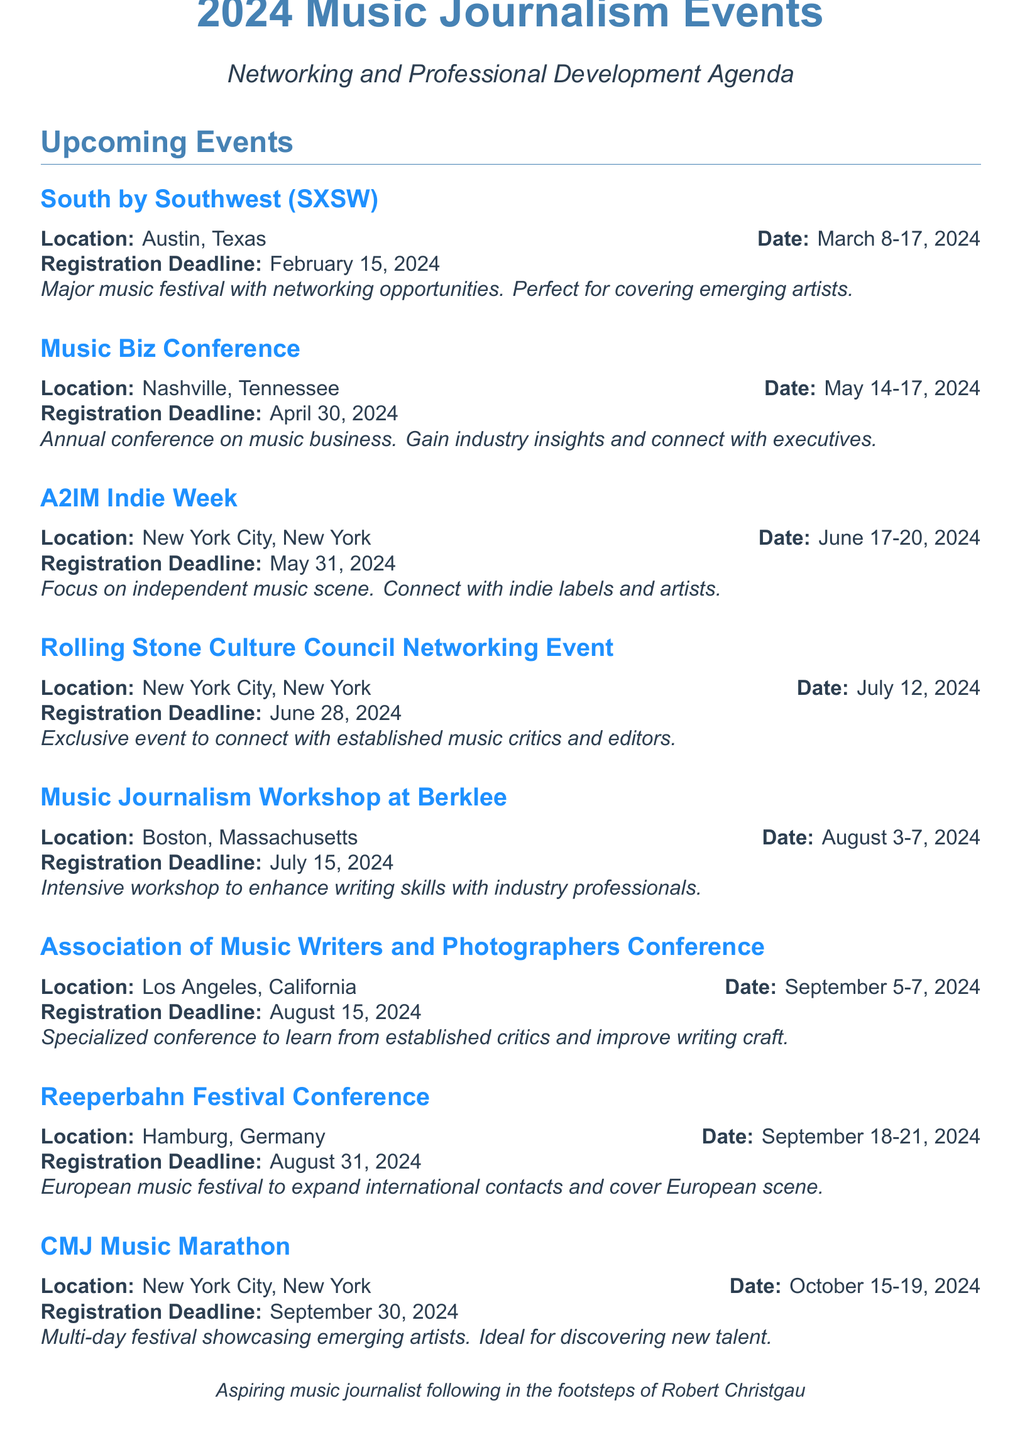What is the location of SXSW? The location of SXSW is specified in the event entry of the document as Austin, Texas.
Answer: Austin, Texas What are the dates for the Music Biz Conference? The dates for the Music Biz Conference are clearly mentioned in the document under the event entry.
Answer: May 14-17, 2024 When is the registration deadline for the Reeperbahn Festival Conference? The registration deadline is stated in the document for the Reeperbahn Festival Conference.
Answer: August 31, 2024 Which event focuses on independent music? The document highlights that A2IM Indie Week focuses on independent music.
Answer: A2IM Indie Week What is the primary purpose of the Association of Music Writers and Photographers Conference? The document describes the conference's purpose as being specialized for music journalists and to improve writing craft.
Answer: Improve writing craft How many days does the Music Journalism Workshop at Berklee last? The document states the duration of the workshop in the event entry.
Answer: Five days Which city hosts the Rolling Stone Culture Council Networking Event? The location of the event is mentioned in the entry of the document.
Answer: New York City, New York What type of event is described for October 15-19, 2024? The document categorizes this event as a multi-day festival focused on emerging artists.
Answer: Multi-day festival 